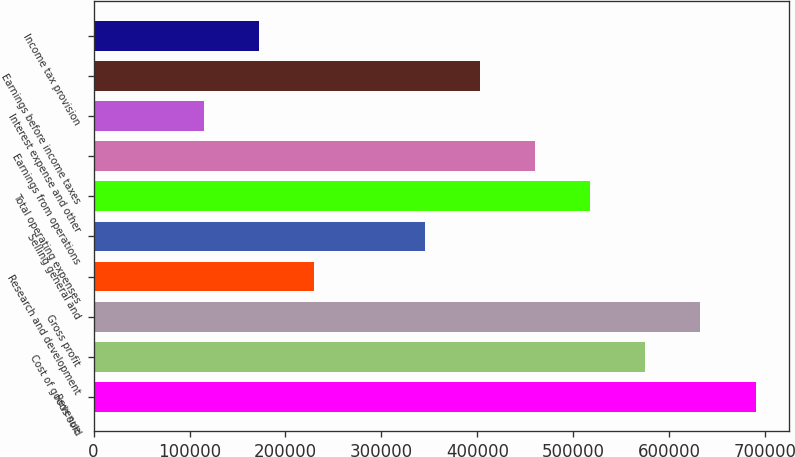Convert chart. <chart><loc_0><loc_0><loc_500><loc_500><bar_chart><fcel>Revenue<fcel>Cost of goods sold<fcel>Gross profit<fcel>Research and development<fcel>Selling general and<fcel>Total operating expenses<fcel>Earnings from operations<fcel>Interest expense and other<fcel>Earnings before income taxes<fcel>Income tax provision<nl><fcel>690000<fcel>575000<fcel>632500<fcel>230001<fcel>345001<fcel>517500<fcel>460000<fcel>115001<fcel>402500<fcel>172501<nl></chart> 